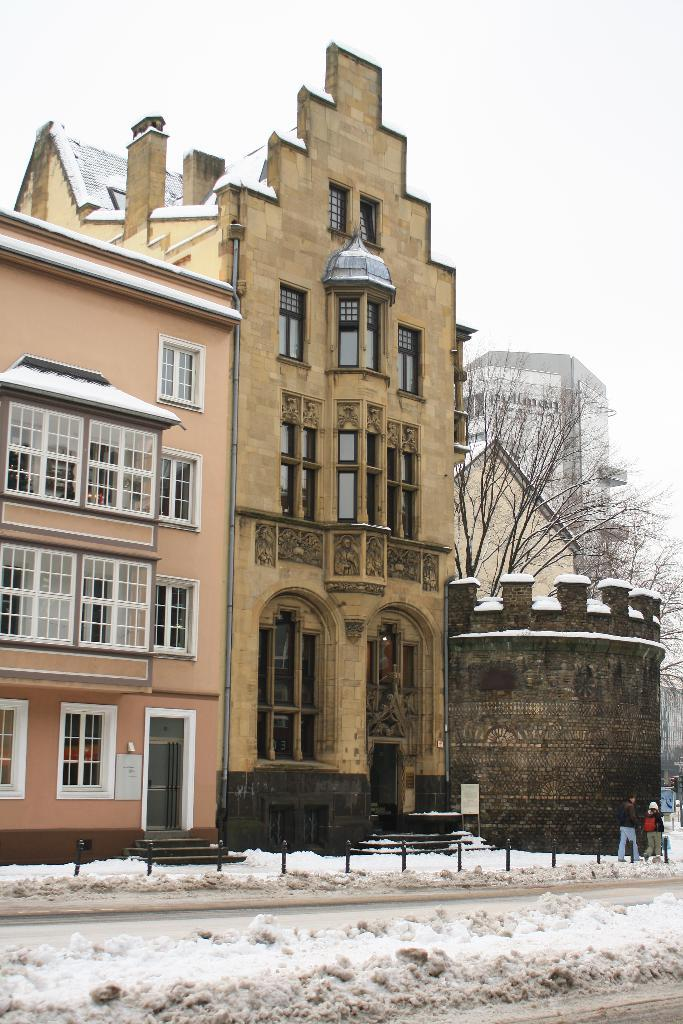What type of structures can be seen in the background of the image? There are buildings with many windows in the background of the image. What are the two persons in the image doing? The two persons are walking on the right side of the image. How is the road in the image affected by the weather? The road is covered with snow. What part of the natural environment is visible in the image? The sky is visible above the road. Can you see a river flowing under the snow-covered road in the image? There is no river visible in the image; it only shows a snow-covered road and buildings in the background. Are there any bubbles floating in the sky above the road? There are no bubbles present in the image; it only shows the sky above the road. 